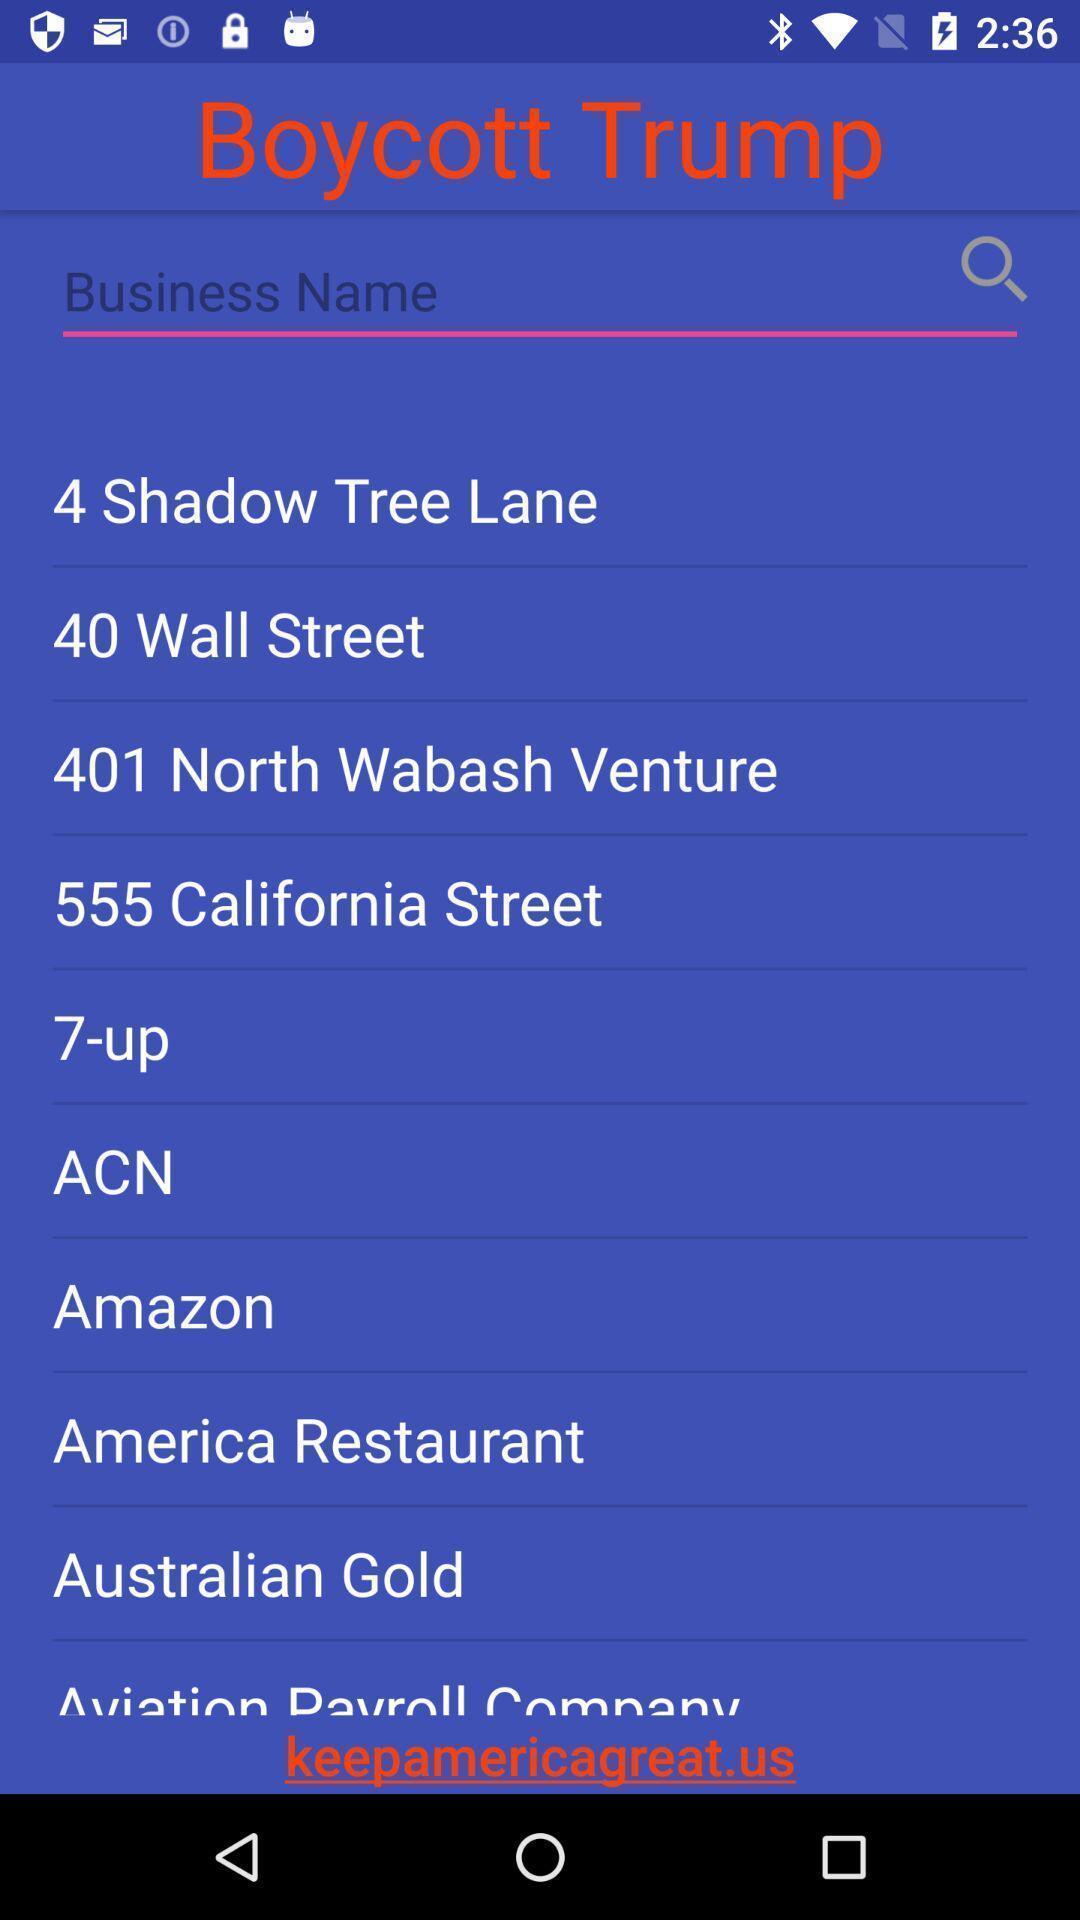Summarize the information in this screenshot. Screen displaying multiple business names and a search bar. 